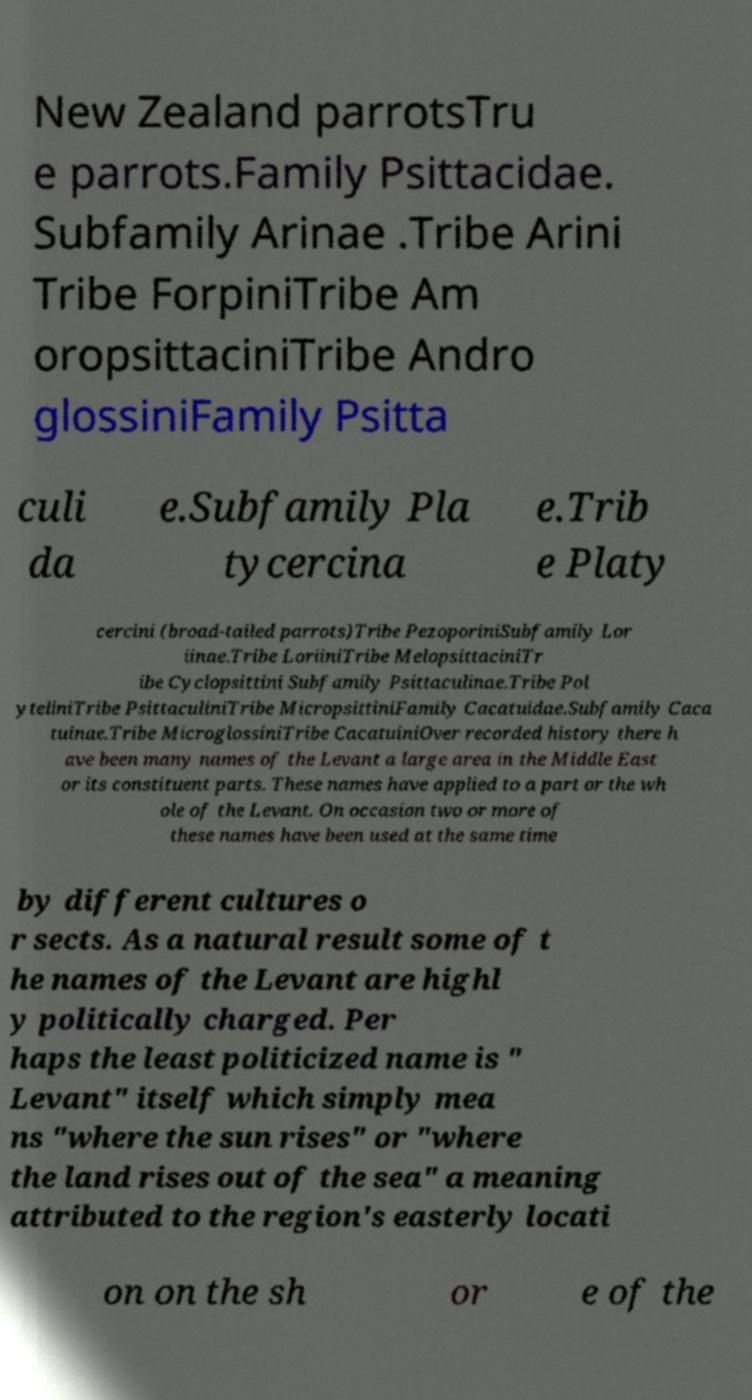Can you read and provide the text displayed in the image?This photo seems to have some interesting text. Can you extract and type it out for me? New Zealand parrotsTru e parrots.Family Psittacidae. Subfamily Arinae .Tribe Arini Tribe ForpiniTribe Am oropsittaciniTribe Andro glossiniFamily Psitta culi da e.Subfamily Pla tycercina e.Trib e Platy cercini (broad-tailed parrots)Tribe PezoporiniSubfamily Lor iinae.Tribe LoriiniTribe MelopsittaciniTr ibe Cyclopsittini Subfamily Psittaculinae.Tribe Pol yteliniTribe PsittaculiniTribe MicropsittiniFamily Cacatuidae.Subfamily Caca tuinae.Tribe MicroglossiniTribe CacatuiniOver recorded history there h ave been many names of the Levant a large area in the Middle East or its constituent parts. These names have applied to a part or the wh ole of the Levant. On occasion two or more of these names have been used at the same time by different cultures o r sects. As a natural result some of t he names of the Levant are highl y politically charged. Per haps the least politicized name is " Levant" itself which simply mea ns "where the sun rises" or "where the land rises out of the sea" a meaning attributed to the region's easterly locati on on the sh or e of the 